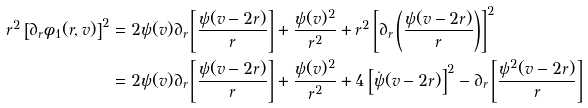Convert formula to latex. <formula><loc_0><loc_0><loc_500><loc_500>r ^ { 2 } \left [ \partial _ { r } \phi _ { 1 } ( r , v ) \right ] ^ { 2 } & = 2 \psi ( v ) \partial _ { r } \left [ \frac { \psi ( v - 2 r ) } { r } \right ] + \frac { \psi ( v ) ^ { 2 } } { r ^ { 2 } } + r ^ { 2 } \left [ \partial _ { r } \left ( \frac { \psi ( v - 2 r ) } { r } \right ) \right ] ^ { 2 } \\ & = 2 \psi ( v ) \partial _ { r } \left [ \frac { \psi ( v - 2 r ) } { r } \right ] + \frac { \psi ( v ) ^ { 2 } } { r ^ { 2 } } + 4 \left [ { \dot { \psi } } ( v - 2 r ) \right ] ^ { 2 } - \partial _ { r } \left [ \frac { \psi ^ { 2 } ( v - 2 r ) } { r } \right ]</formula> 